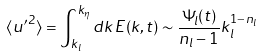Convert formula to latex. <formula><loc_0><loc_0><loc_500><loc_500>\langle { u ^ { \prime } } ^ { 2 } \rangle = \int _ { k _ { l } } ^ { k _ { \eta } } d k \, E ( k , t ) \sim \frac { \Psi _ { l } ( t ) } { n _ { l } - 1 } k _ { l } ^ { 1 - n _ { l } }</formula> 